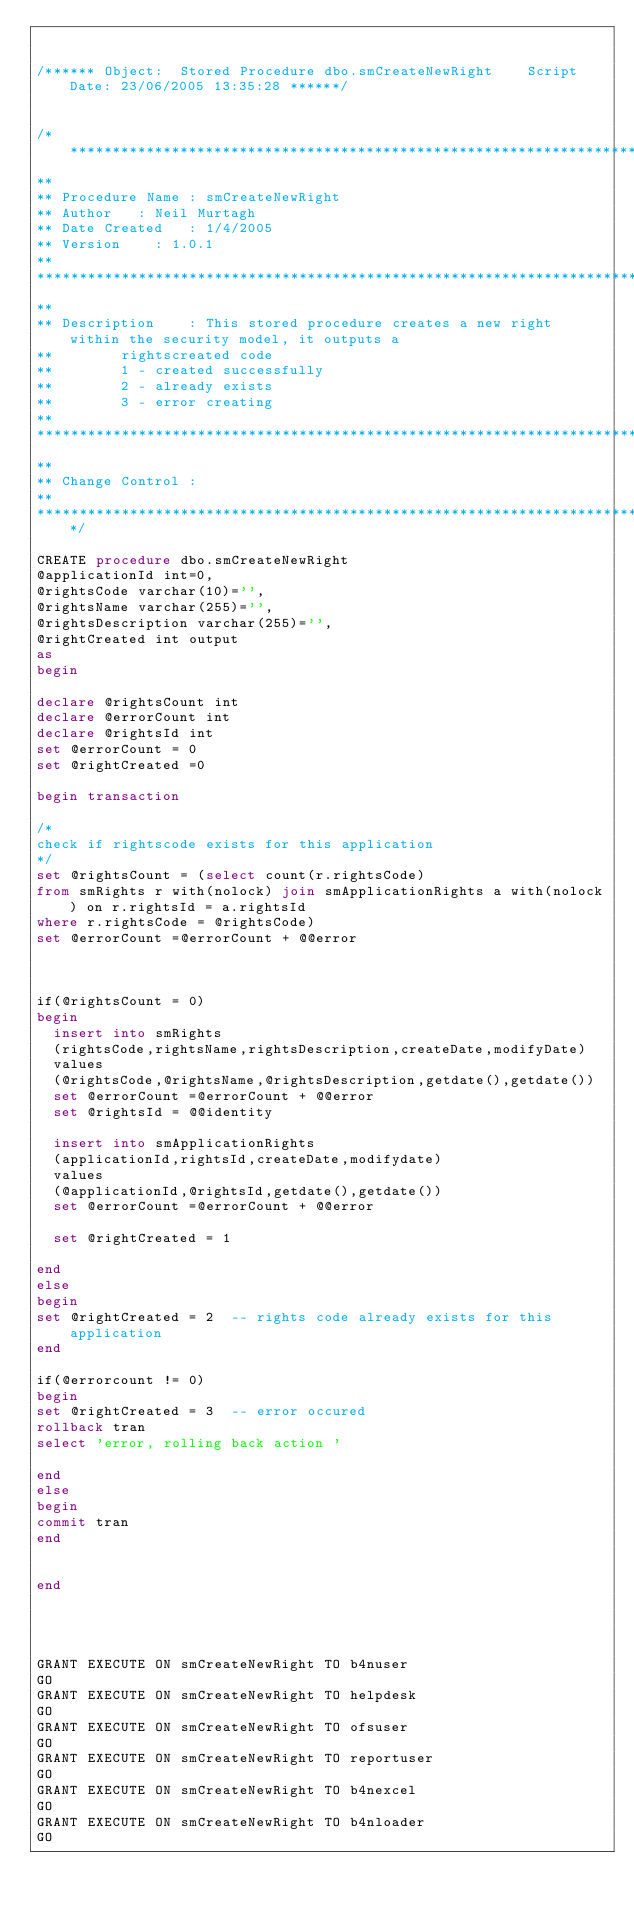Convert code to text. <code><loc_0><loc_0><loc_500><loc_500><_SQL_>

/****** Object:  Stored Procedure dbo.smCreateNewRight    Script Date: 23/06/2005 13:35:28 ******/


/*********************************************************************************************************************
**																					
** Procedure Name	:	smCreateNewRight
** Author		:	Neil Murtagh	
** Date Created		:	1/4/2005
** Version		:	1.0.1
**					
**********************************************************************************************************************
**				
** Description		:	This stored procedure creates a new right within the security model, it outputs a
**				rightscreated code
**				1 - created successfully
**				2 - already exists
**				3 - error creating
**					
**********************************************************************************************************************
**									
** Change Control	:	
**						
**********************************************************************************************************************/
 						
CREATE procedure dbo.smCreateNewRight
@applicationId int=0,
@rightsCode varchar(10)='',
@rightsName varchar(255)='',
@rightsDescription varchar(255)='',
@rightCreated int output
as
begin

declare @rightsCount int
declare @errorCount int
declare @rightsId int
set @errorCount = 0
set @rightCreated =0

begin transaction

/*
check if rightscode exists for this application 
*/
set @rightsCount = (select count(r.rightsCode) 
from smRights r with(nolock) join smApplicationRights a with(nolock) on r.rightsId = a.rightsId
where r.rightsCode = @rightsCode)
set @errorCount =@errorCount + @@error 



if(@rightsCount = 0)
begin
	insert into smRights
	(rightsCode,rightsName,rightsDescription,createDate,modifyDate)
	values
	(@rightsCode,@rightsName,@rightsDescription,getdate(),getdate())
	set @errorCount =@errorCount + @@error 
	set @rightsId = @@identity
	
	insert into smApplicationRights
	(applicationId,rightsId,createDate,modifydate)
	values
	(@applicationId,@rightsId,getdate(),getdate())
	set @errorCount =@errorCount + @@error 
	
	set @rightCreated = 1
	
end
else
begin
set @rightCreated = 2  -- rights code already exists for this application
end

if(@errorcount != 0)
begin
set @rightCreated = 3  -- error occured
rollback tran
select 'error, rolling back action '

end
else
begin
commit tran
end


end




GRANT EXECUTE ON smCreateNewRight TO b4nuser
GO
GRANT EXECUTE ON smCreateNewRight TO helpdesk
GO
GRANT EXECUTE ON smCreateNewRight TO ofsuser
GO
GRANT EXECUTE ON smCreateNewRight TO reportuser
GO
GRANT EXECUTE ON smCreateNewRight TO b4nexcel
GO
GRANT EXECUTE ON smCreateNewRight TO b4nloader
GO
</code> 